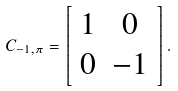<formula> <loc_0><loc_0><loc_500><loc_500>C _ { - 1 , \pi } = \left [ \begin{array} { c c } 1 & 0 \\ 0 & - 1 \\ \end{array} \right ] .</formula> 